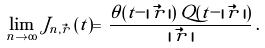<formula> <loc_0><loc_0><loc_500><loc_500>\lim _ { n \to \infty } \, J _ { n , \vec { r } } \, ( t ) = \, \frac { \theta ( t - | \, \vec { r } \, | ) \, Q ( t - | \, \vec { r } \, | ) } { | \, \vec { r } \, | } \, .</formula> 